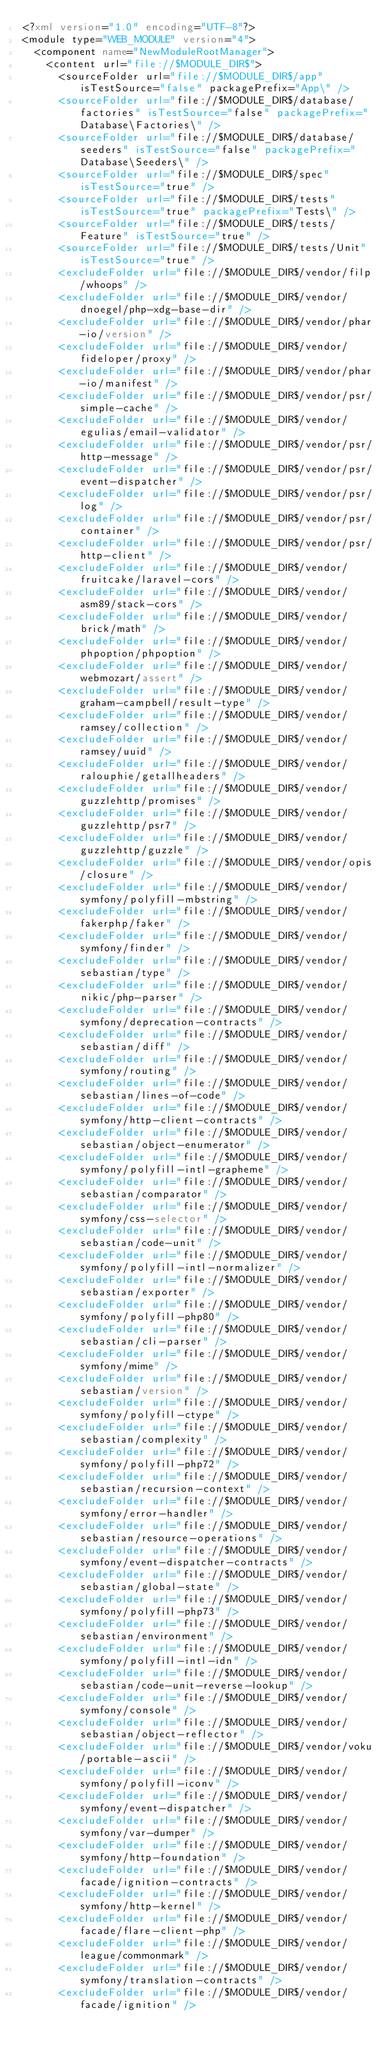<code> <loc_0><loc_0><loc_500><loc_500><_XML_><?xml version="1.0" encoding="UTF-8"?>
<module type="WEB_MODULE" version="4">
  <component name="NewModuleRootManager">
    <content url="file://$MODULE_DIR$">
      <sourceFolder url="file://$MODULE_DIR$/app" isTestSource="false" packagePrefix="App\" />
      <sourceFolder url="file://$MODULE_DIR$/database/factories" isTestSource="false" packagePrefix="Database\Factories\" />
      <sourceFolder url="file://$MODULE_DIR$/database/seeders" isTestSource="false" packagePrefix="Database\Seeders\" />
      <sourceFolder url="file://$MODULE_DIR$/spec" isTestSource="true" />
      <sourceFolder url="file://$MODULE_DIR$/tests" isTestSource="true" packagePrefix="Tests\" />
      <sourceFolder url="file://$MODULE_DIR$/tests/Feature" isTestSource="true" />
      <sourceFolder url="file://$MODULE_DIR$/tests/Unit" isTestSource="true" />
      <excludeFolder url="file://$MODULE_DIR$/vendor/filp/whoops" />
      <excludeFolder url="file://$MODULE_DIR$/vendor/dnoegel/php-xdg-base-dir" />
      <excludeFolder url="file://$MODULE_DIR$/vendor/phar-io/version" />
      <excludeFolder url="file://$MODULE_DIR$/vendor/fideloper/proxy" />
      <excludeFolder url="file://$MODULE_DIR$/vendor/phar-io/manifest" />
      <excludeFolder url="file://$MODULE_DIR$/vendor/psr/simple-cache" />
      <excludeFolder url="file://$MODULE_DIR$/vendor/egulias/email-validator" />
      <excludeFolder url="file://$MODULE_DIR$/vendor/psr/http-message" />
      <excludeFolder url="file://$MODULE_DIR$/vendor/psr/event-dispatcher" />
      <excludeFolder url="file://$MODULE_DIR$/vendor/psr/log" />
      <excludeFolder url="file://$MODULE_DIR$/vendor/psr/container" />
      <excludeFolder url="file://$MODULE_DIR$/vendor/psr/http-client" />
      <excludeFolder url="file://$MODULE_DIR$/vendor/fruitcake/laravel-cors" />
      <excludeFolder url="file://$MODULE_DIR$/vendor/asm89/stack-cors" />
      <excludeFolder url="file://$MODULE_DIR$/vendor/brick/math" />
      <excludeFolder url="file://$MODULE_DIR$/vendor/phpoption/phpoption" />
      <excludeFolder url="file://$MODULE_DIR$/vendor/webmozart/assert" />
      <excludeFolder url="file://$MODULE_DIR$/vendor/graham-campbell/result-type" />
      <excludeFolder url="file://$MODULE_DIR$/vendor/ramsey/collection" />
      <excludeFolder url="file://$MODULE_DIR$/vendor/ramsey/uuid" />
      <excludeFolder url="file://$MODULE_DIR$/vendor/ralouphie/getallheaders" />
      <excludeFolder url="file://$MODULE_DIR$/vendor/guzzlehttp/promises" />
      <excludeFolder url="file://$MODULE_DIR$/vendor/guzzlehttp/psr7" />
      <excludeFolder url="file://$MODULE_DIR$/vendor/guzzlehttp/guzzle" />
      <excludeFolder url="file://$MODULE_DIR$/vendor/opis/closure" />
      <excludeFolder url="file://$MODULE_DIR$/vendor/symfony/polyfill-mbstring" />
      <excludeFolder url="file://$MODULE_DIR$/vendor/fakerphp/faker" />
      <excludeFolder url="file://$MODULE_DIR$/vendor/symfony/finder" />
      <excludeFolder url="file://$MODULE_DIR$/vendor/sebastian/type" />
      <excludeFolder url="file://$MODULE_DIR$/vendor/nikic/php-parser" />
      <excludeFolder url="file://$MODULE_DIR$/vendor/symfony/deprecation-contracts" />
      <excludeFolder url="file://$MODULE_DIR$/vendor/sebastian/diff" />
      <excludeFolder url="file://$MODULE_DIR$/vendor/symfony/routing" />
      <excludeFolder url="file://$MODULE_DIR$/vendor/sebastian/lines-of-code" />
      <excludeFolder url="file://$MODULE_DIR$/vendor/symfony/http-client-contracts" />
      <excludeFolder url="file://$MODULE_DIR$/vendor/sebastian/object-enumerator" />
      <excludeFolder url="file://$MODULE_DIR$/vendor/symfony/polyfill-intl-grapheme" />
      <excludeFolder url="file://$MODULE_DIR$/vendor/sebastian/comparator" />
      <excludeFolder url="file://$MODULE_DIR$/vendor/symfony/css-selector" />
      <excludeFolder url="file://$MODULE_DIR$/vendor/sebastian/code-unit" />
      <excludeFolder url="file://$MODULE_DIR$/vendor/symfony/polyfill-intl-normalizer" />
      <excludeFolder url="file://$MODULE_DIR$/vendor/sebastian/exporter" />
      <excludeFolder url="file://$MODULE_DIR$/vendor/symfony/polyfill-php80" />
      <excludeFolder url="file://$MODULE_DIR$/vendor/sebastian/cli-parser" />
      <excludeFolder url="file://$MODULE_DIR$/vendor/symfony/mime" />
      <excludeFolder url="file://$MODULE_DIR$/vendor/sebastian/version" />
      <excludeFolder url="file://$MODULE_DIR$/vendor/symfony/polyfill-ctype" />
      <excludeFolder url="file://$MODULE_DIR$/vendor/sebastian/complexity" />
      <excludeFolder url="file://$MODULE_DIR$/vendor/symfony/polyfill-php72" />
      <excludeFolder url="file://$MODULE_DIR$/vendor/sebastian/recursion-context" />
      <excludeFolder url="file://$MODULE_DIR$/vendor/symfony/error-handler" />
      <excludeFolder url="file://$MODULE_DIR$/vendor/sebastian/resource-operations" />
      <excludeFolder url="file://$MODULE_DIR$/vendor/symfony/event-dispatcher-contracts" />
      <excludeFolder url="file://$MODULE_DIR$/vendor/sebastian/global-state" />
      <excludeFolder url="file://$MODULE_DIR$/vendor/symfony/polyfill-php73" />
      <excludeFolder url="file://$MODULE_DIR$/vendor/sebastian/environment" />
      <excludeFolder url="file://$MODULE_DIR$/vendor/symfony/polyfill-intl-idn" />
      <excludeFolder url="file://$MODULE_DIR$/vendor/sebastian/code-unit-reverse-lookup" />
      <excludeFolder url="file://$MODULE_DIR$/vendor/symfony/console" />
      <excludeFolder url="file://$MODULE_DIR$/vendor/sebastian/object-reflector" />
      <excludeFolder url="file://$MODULE_DIR$/vendor/voku/portable-ascii" />
      <excludeFolder url="file://$MODULE_DIR$/vendor/symfony/polyfill-iconv" />
      <excludeFolder url="file://$MODULE_DIR$/vendor/symfony/event-dispatcher" />
      <excludeFolder url="file://$MODULE_DIR$/vendor/symfony/var-dumper" />
      <excludeFolder url="file://$MODULE_DIR$/vendor/symfony/http-foundation" />
      <excludeFolder url="file://$MODULE_DIR$/vendor/facade/ignition-contracts" />
      <excludeFolder url="file://$MODULE_DIR$/vendor/symfony/http-kernel" />
      <excludeFolder url="file://$MODULE_DIR$/vendor/facade/flare-client-php" />
      <excludeFolder url="file://$MODULE_DIR$/vendor/league/commonmark" />
      <excludeFolder url="file://$MODULE_DIR$/vendor/symfony/translation-contracts" />
      <excludeFolder url="file://$MODULE_DIR$/vendor/facade/ignition" /></code> 